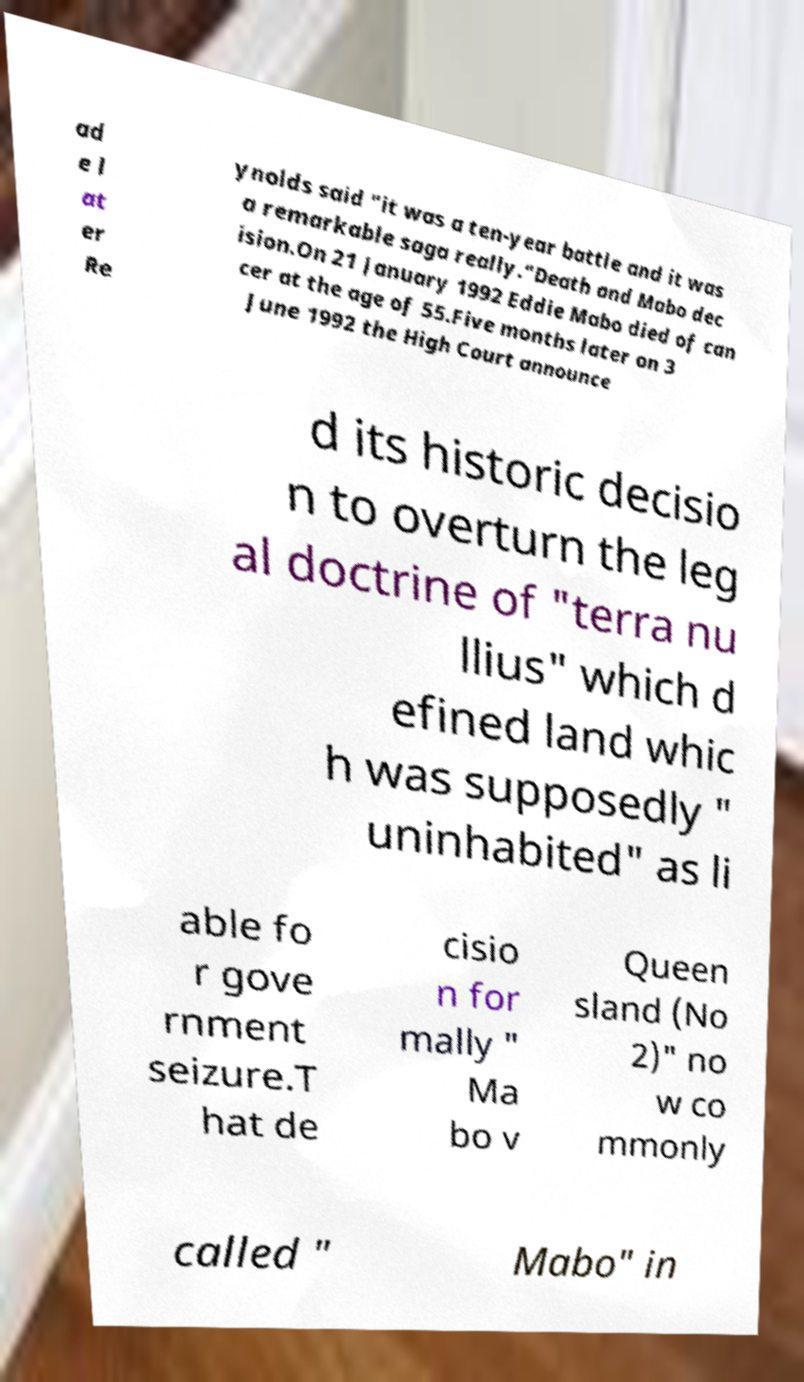I need the written content from this picture converted into text. Can you do that? ad e l at er Re ynolds said "it was a ten-year battle and it was a remarkable saga really."Death and Mabo dec ision.On 21 January 1992 Eddie Mabo died of can cer at the age of 55.Five months later on 3 June 1992 the High Court announce d its historic decisio n to overturn the leg al doctrine of "terra nu llius" which d efined land whic h was supposedly " uninhabited" as li able fo r gove rnment seizure.T hat de cisio n for mally " Ma bo v Queen sland (No 2)" no w co mmonly called " Mabo" in 